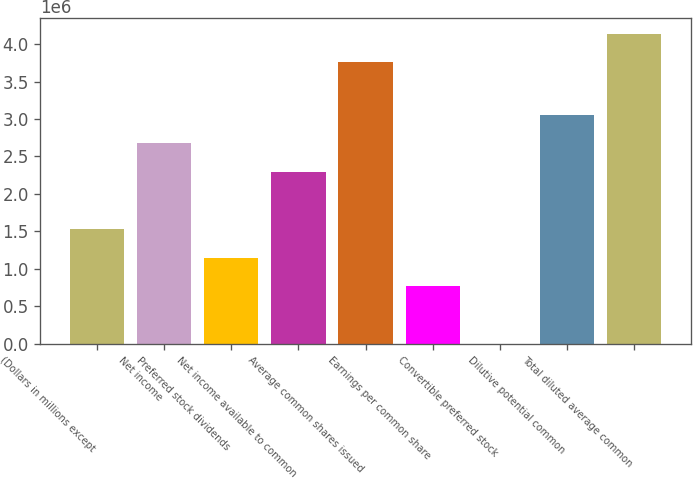Convert chart. <chart><loc_0><loc_0><loc_500><loc_500><bar_chart><fcel>(Dollars in millions except<fcel>Net income<fcel>Preferred stock dividends<fcel>Net income available to common<fcel>Average common shares issued<fcel>Earnings per common share<fcel>Convertible preferred stock<fcel>Dilutive potential common<fcel>Total diluted average common<nl><fcel>1.52958e+06<fcel>2.67676e+06<fcel>1.14718e+06<fcel>2.29437e+06<fcel>3.75851e+06<fcel>764790<fcel>2<fcel>3.05915e+06<fcel>4.1409e+06<nl></chart> 